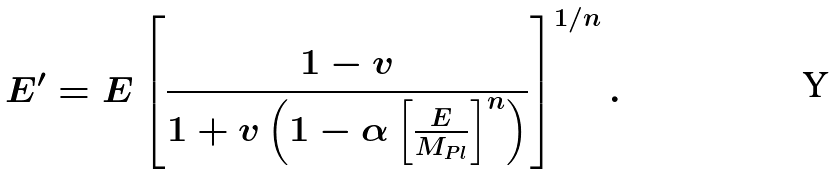<formula> <loc_0><loc_0><loc_500><loc_500>E ^ { \prime } = E \left [ \frac { 1 - v } { 1 + v \left ( 1 - \alpha \left [ \frac { E } { M _ { P l } } \right ] ^ { n } \right ) } \right ] ^ { 1 / n } .</formula> 